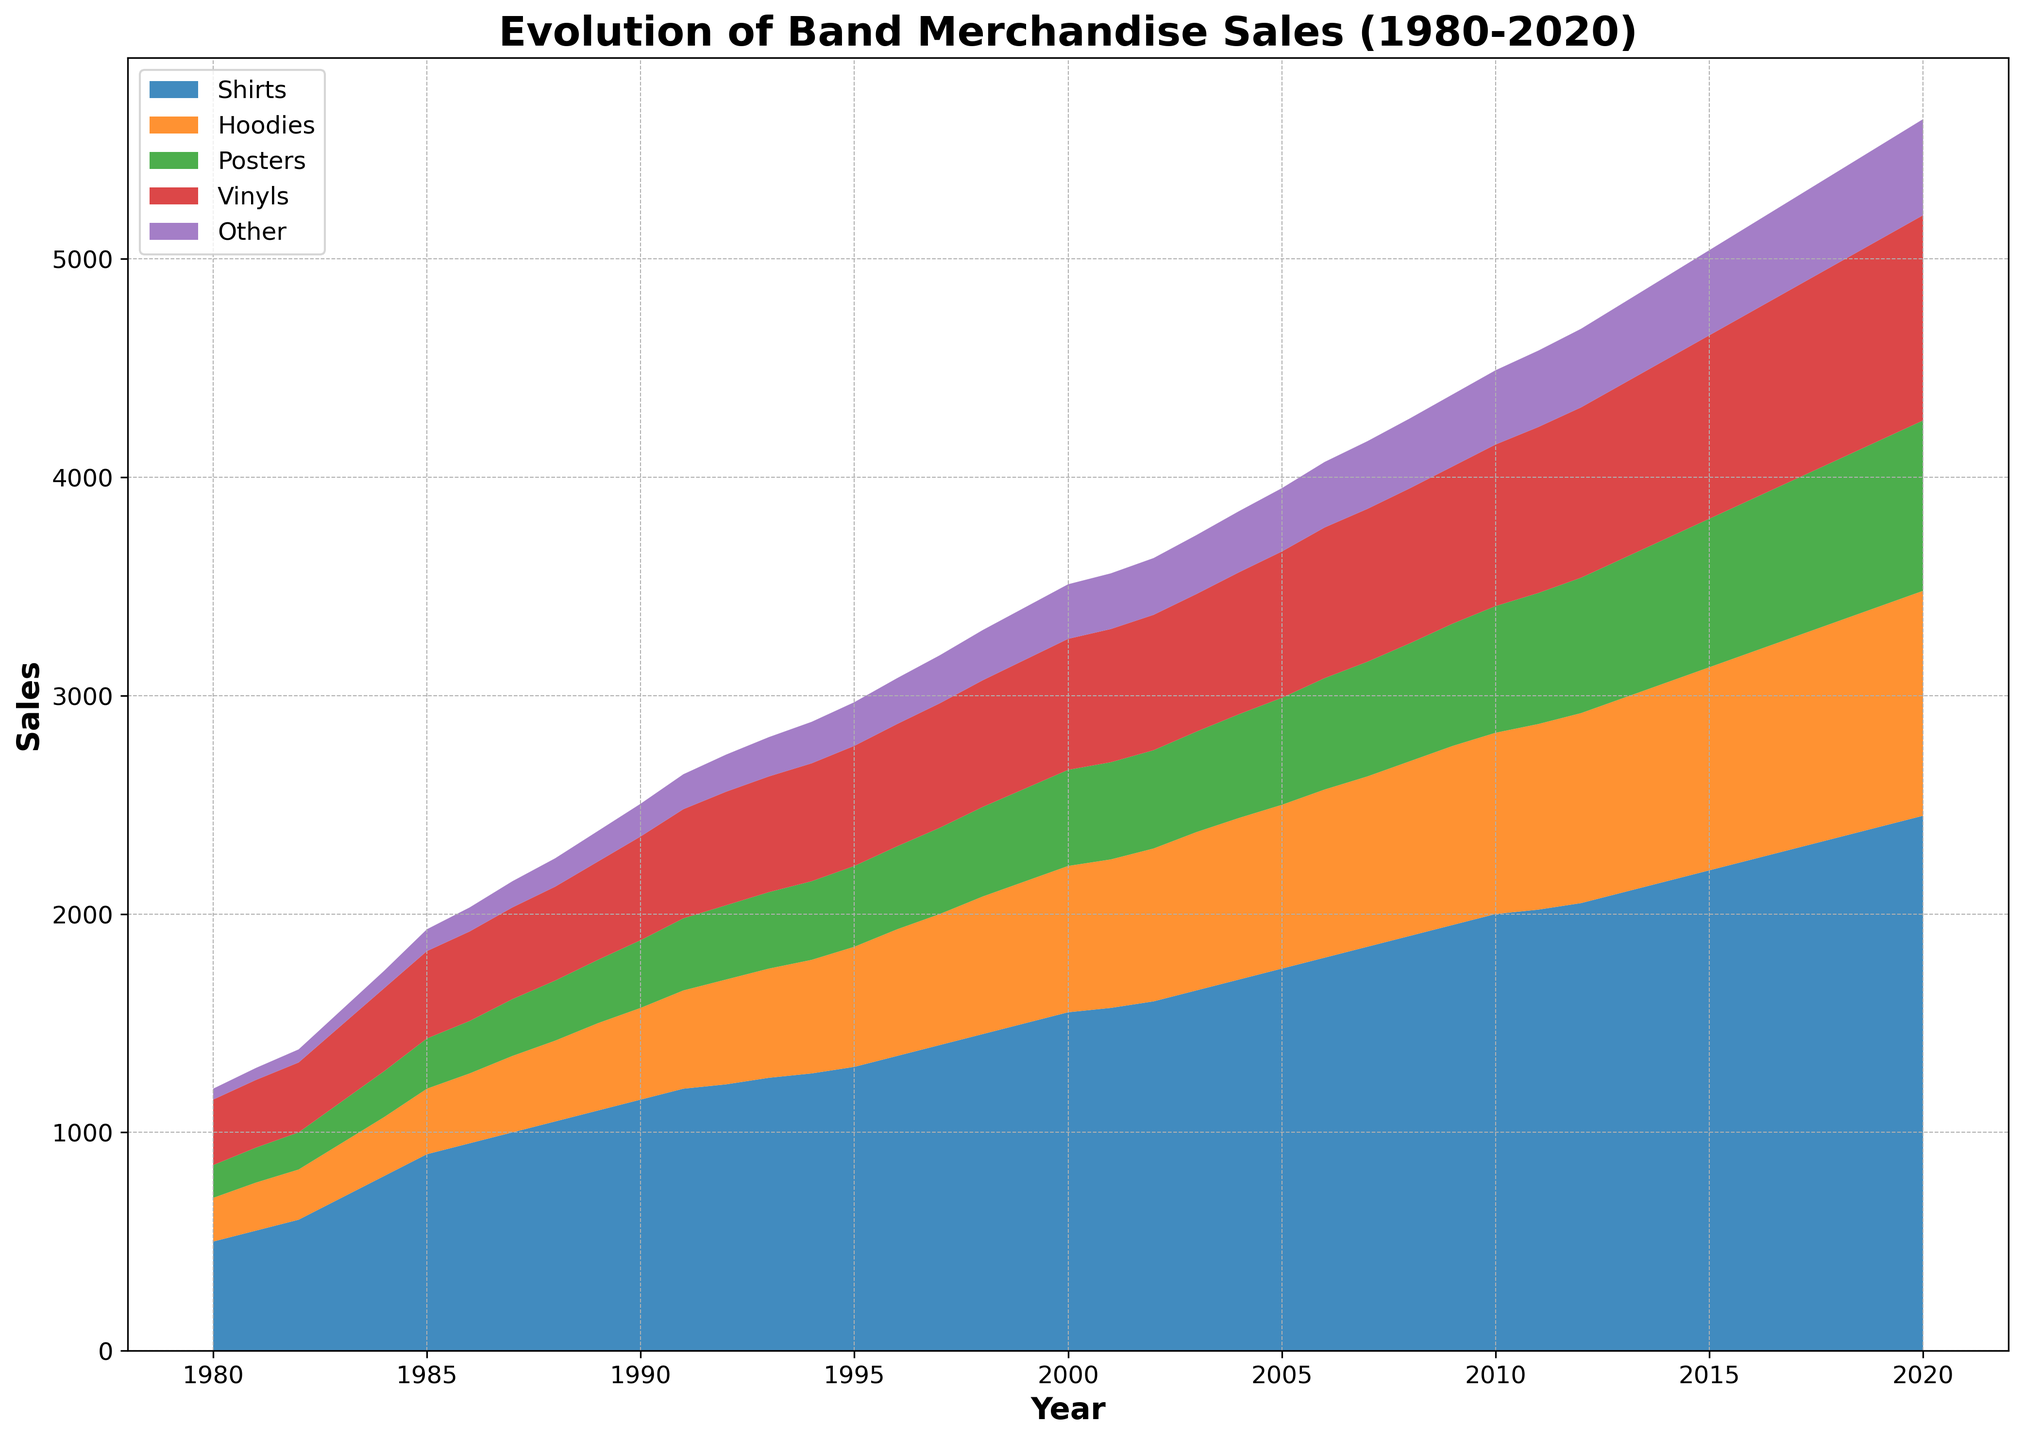What was the total sales of merchandise in 1980? To find the total sales in 1980, add the sales of Shirts, Hoodies, Posters, Vinyls, and Other. The total is 500 (Shirts) + 200 (Hoodies) + 150 (Posters) + 300 (Vinyls) + 50 (Other) = 1200.
Answer: 1200 Which year had the highest sales of Hoodies? By examining the chart and noting the peak value in the Hoodies category, we see that the highest sales occurred in 2020.
Answer: 2020 Between which years did Posters see the largest increase in sales? To find the largest increase, compare the sales of Posters between consecutive years. The largest annual increase can be observed between 2006 and 2007: 525 (2007) - 510 (2006) = 15.
Answer: 2006 and 2007 In which year did sales of Vinyls surpass 700 for the first time? Examine the graph for the Vinyls category until the sales exceed 700. This occurred in 2015.
Answer: 2015 Compare the sales of Hoodies and Posters in 1995. Which was higher, and by how much? In 1995, Hoodies sold 550 units, and Posters sold 370 units. To find the difference, subtract: 550 - 370 = 180. Hoodies were higher by 180.
Answer: Hoodies, 180 What is the average annual growth rate in Shirt sales from 1980 to 2020? To find the average annual growth rate: 
1. Calculate the total growth over the period: 2450 (2020) - 500 (1980) = 1950.
2. Divide by the number of years: 1950 / 40 = 48.75.
The average annual growth rate of Shirt sales is about 48.75 units per year.
Answer: 48.75 units/year How did sales of 'Other' merchandise change from 2000 to 2020? In 2000, sales were 250, and in 2020, they were 440. The change is 440 - 250 = 190, indicating an increase of 190 units over 20 years.
Answer: Increased by 190 units Which category showed the most consistent growth over the entire period? By viewing the graph, we observe that Shirt sales consistently increase each year without any decreases, indicating the most consistent growth.
Answer: Shirts In 2010, what was the combined total of Hoodie and Vinyl sales? To find the combined total for 2010: 830 (Hoodies) + 740 (Vinyls) = 1570.
Answer: 1570 What trend can be observed in sales of Posters from 1980 to 2020? Examine the graph for Posters where sales consistently increase over the entire period.
Answer: Consistent increase 